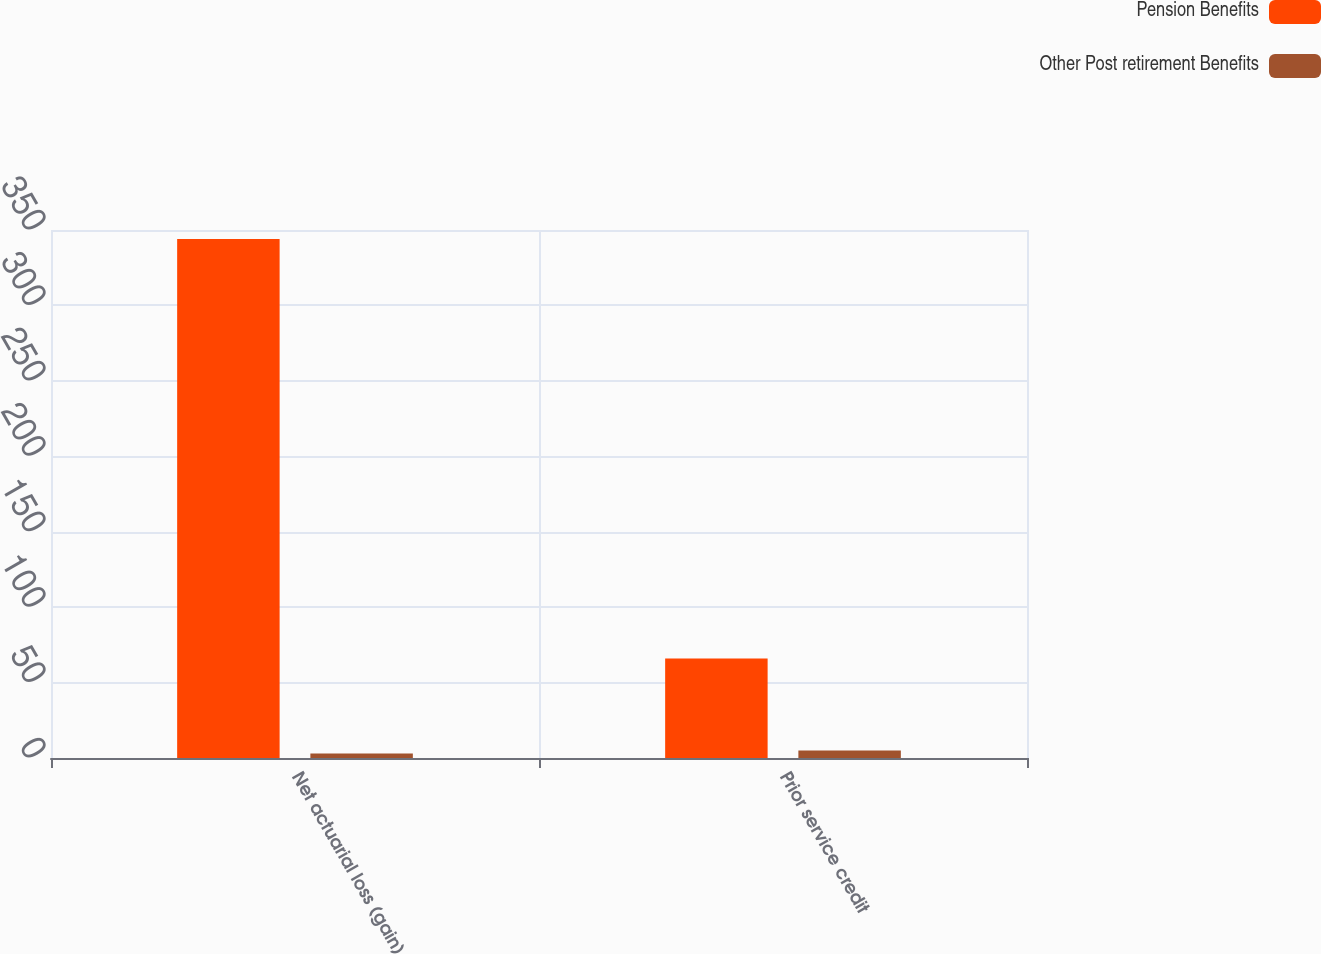Convert chart to OTSL. <chart><loc_0><loc_0><loc_500><loc_500><stacked_bar_chart><ecel><fcel>Net actuarial loss (gain)<fcel>Prior service credit<nl><fcel>Pension Benefits<fcel>344<fcel>66<nl><fcel>Other Post retirement Benefits<fcel>3<fcel>5<nl></chart> 